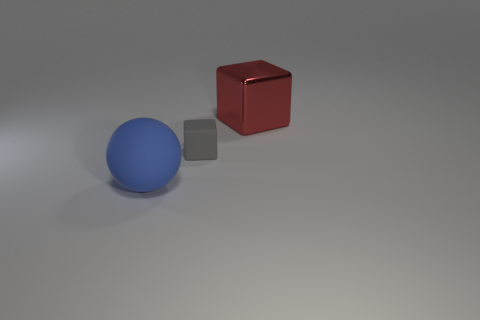Add 1 tiny yellow matte spheres. How many objects exist? 4 Subtract all balls. How many objects are left? 2 Add 1 large objects. How many large objects are left? 3 Add 2 large red objects. How many large red objects exist? 3 Subtract 0 purple cubes. How many objects are left? 3 Subtract all big blue balls. Subtract all small yellow blocks. How many objects are left? 2 